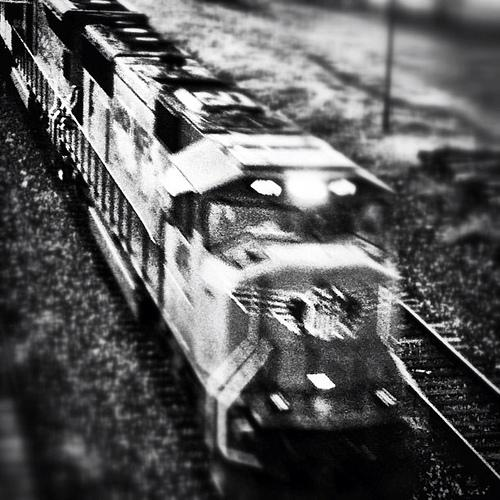Give a brief description of the image focusing on the main object and its surroundings. The image features a moving train on railroad tracks, with gravel on the sides and a pole nearby. It is in black and white with some blur and noise on the surface. Analyze the interaction between the train and its surroundings. The train is running on railroad tracks while surrounded by gravel, with a single post on the side of the tracks. Identify the type of vehicle present in the image. A train is the main vehicle present in the image. What type of analysis can be performed based on the image's sentiment? An image sentiment analysis task can determine the emotions and sentiments evoked by the image. Are there any captions that mention a specific color related to the rail? If so, what color? Yes, the rail is black. List three parts of the train mentioned in the image captions. Train headlight, windshield, and a bar on the engine. What is the primary action in this picture? A train is running on railroad tracks surrounded by gravel. Describe the condition of the photo in terms of color and quality. The photo is in black and white and contains a lot of noise on the surface. Determine the quality of the image in terms of noise and blurriness. The image contains a lot of noise on the surface and has blurry parts, such as (161, 256), (222, 319), and (241, 277). Please notice the tree next to the train track. It's quite tall and has green leaves. There are no trees mentioned in the given image information. Additionally, the image is in black and white, so mentioning "green leaves" adds another layer of deception. Describe the interaction between the train engine and the train tracks. The train engine is running on the train tracks, creating a sense of movement and purpose. Does the train appear to be moving, stopped, or parked in the image?  The train appears to be moving in the image. What emotions or feelings does this black and white image of a moving train evoke? The image evokes a sense of nostalgia, movement, and industrial progress. Where is the bicycle chained to the pole by the train? It seems to be left by someone who took the train earlier. There is no mention of a bicycle anywhere in the given image information, so this directs attention to an object that doesn't exist in the image. Identify the objects and their locations in the photo. headlight at (248, 172), windshield at (201, 195), train front at (188, 160), train engine at (66, 28), train tracks at (348, 251), gravel at (3, 131), train at (1, 0), pole at (373, 0), bar on engine at (201, 340), logo at (286, 281), black rail at (431, 320), (393, 317), and (395, 270), empty railroad track at (354, 227), running train at (180, 177), gravel at (5, 142) and (291, 92), lights at (236, 170), train on tracks at (36, 80), running through gravel at (12, 80), side of train at (21, 83), window at (200, 198), single post at (362, 87), railroad track at (422, 324), train light at (245, 175), wind shield at (194, 190), moving train at (68, 35), noise on surface at (75, 53), black and white at (60, 102), wood planks at (438, 375), metal bars at (51, 87), train engine at (78, 33), train car at (8, 3), blurry train at (161, 256), (222, 319), and (241, 277). Describe the attributes of the black rail in the image. Black rail is at (431, 320), (393, 317), and (395, 270). Identify any text or symbols visible in the image, such as a logo on the train engine. A logo on the train engine at (286, 281). Point out the dog that is walking alongside the gravel near the tracks. It looks curious about the moving train. There is no mention of any animal, specifically a dog, in the given image information. This instruction adds a non-existent subject by asking the viewer to find it in the image. Identify the image segments corresponding to the train engine, train tracks, and gravel. Train engine at (66, 28), train tracks at (348, 251), and gravel at (3, 131), (5, 142), and (291, 92). Locate the train's headlight and the engineer's windshield in the image. Headlight at (248, 172); engineer's windshield at (194, 190). Locate the passenger standing on the platform and waiting for the train to stop. They seem to be checking their watch. There are no passengers mentioned in the given image information, and there's no platform referenced either, making this instruction misleading. Can you find the hot air balloon floating above the train? It has bright colors and interesting patterns. There is no mention of a hot air balloon in the given image information, so this instruction misleads by introducing an object that does not exist in the image. Are there any unusual or unexpected aspects in the image? The image is in black and white, and some parts of the train are blurry, contributing to an overall noisy and vintage appearance. Observe the reflection of the nearby building on the windshield of the train. You can see the windows and the entrance clearly. There is no mention of a building or its reflection on the windshield in the given image information. This instruction is misleading as it suggests looking for a specific detail that doesn't exist. 